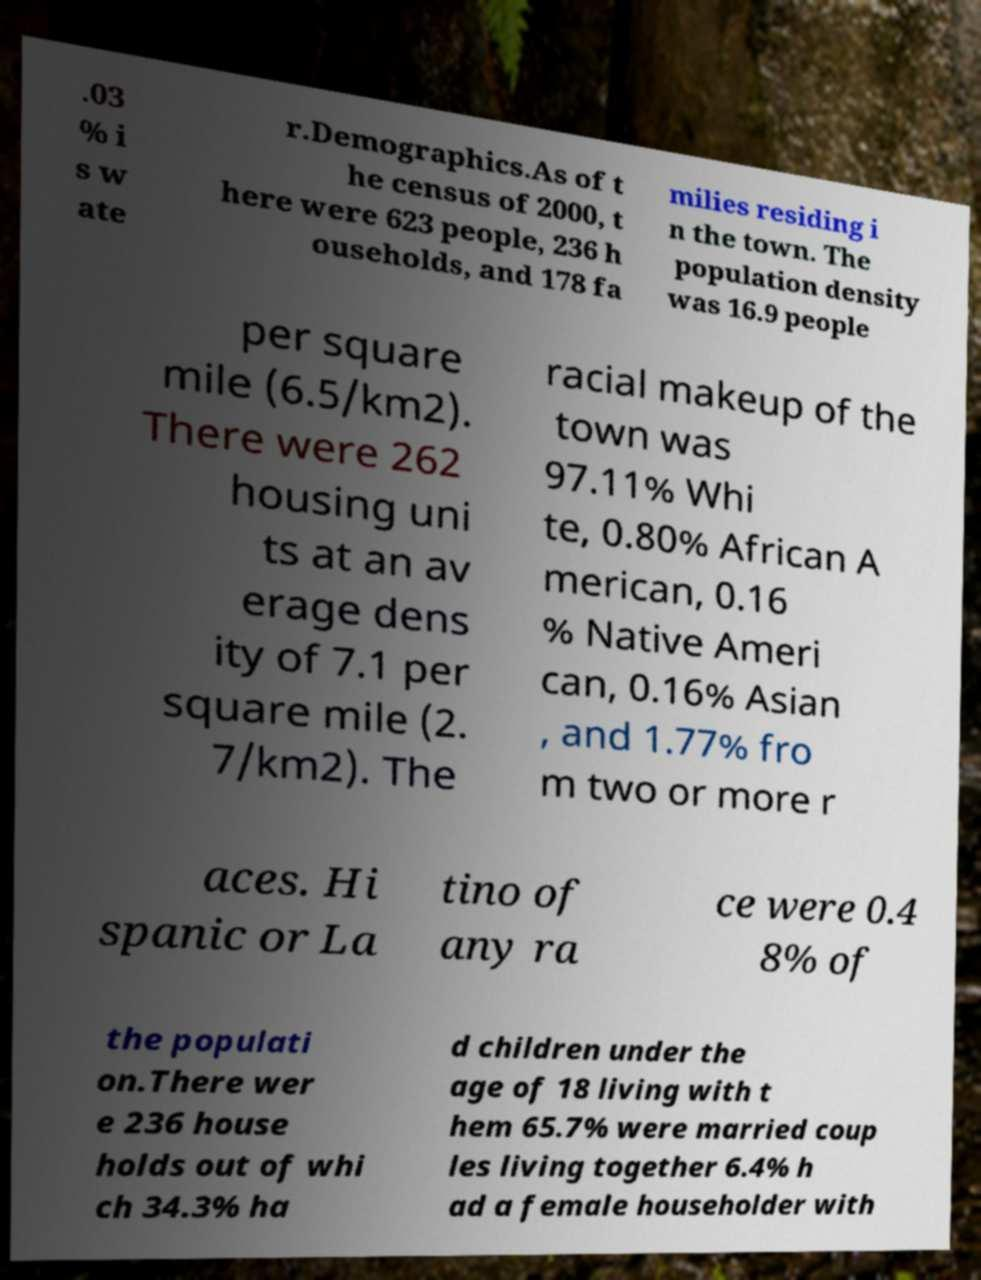Can you read and provide the text displayed in the image?This photo seems to have some interesting text. Can you extract and type it out for me? .03 % i s w ate r.Demographics.As of t he census of 2000, t here were 623 people, 236 h ouseholds, and 178 fa milies residing i n the town. The population density was 16.9 people per square mile (6.5/km2). There were 262 housing uni ts at an av erage dens ity of 7.1 per square mile (2. 7/km2). The racial makeup of the town was 97.11% Whi te, 0.80% African A merican, 0.16 % Native Ameri can, 0.16% Asian , and 1.77% fro m two or more r aces. Hi spanic or La tino of any ra ce were 0.4 8% of the populati on.There wer e 236 house holds out of whi ch 34.3% ha d children under the age of 18 living with t hem 65.7% were married coup les living together 6.4% h ad a female householder with 